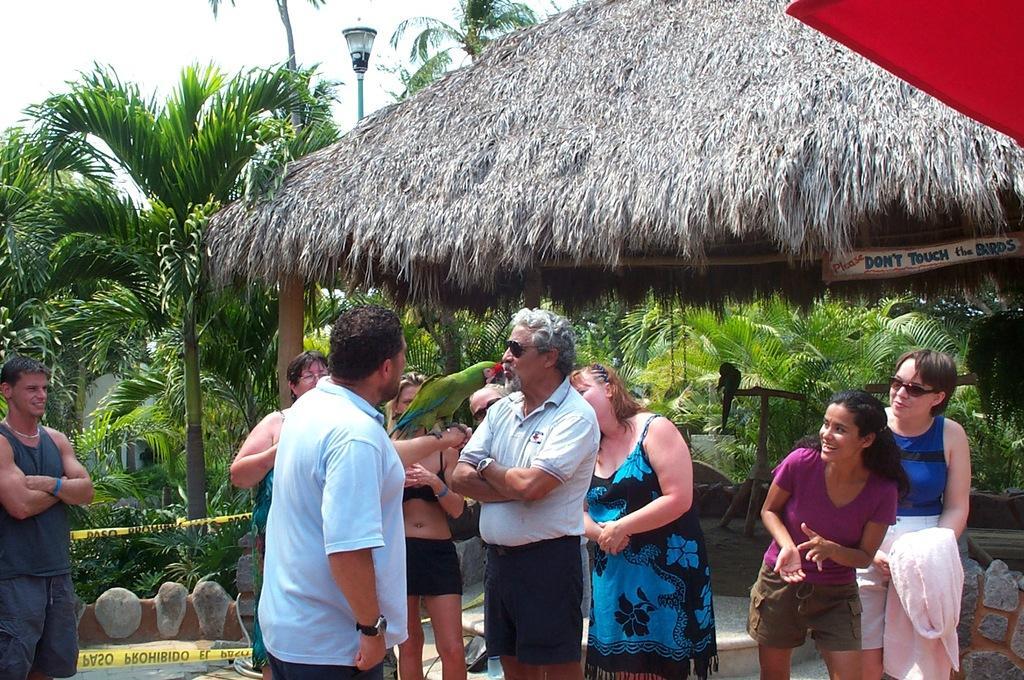How would you summarize this image in a sentence or two? In this image there are a few people standing and there is a bird on the one of the hands of a person, behind them there is a hut, beneath that there is a bird. In the background there are trees, plants, lamp and the sky. 